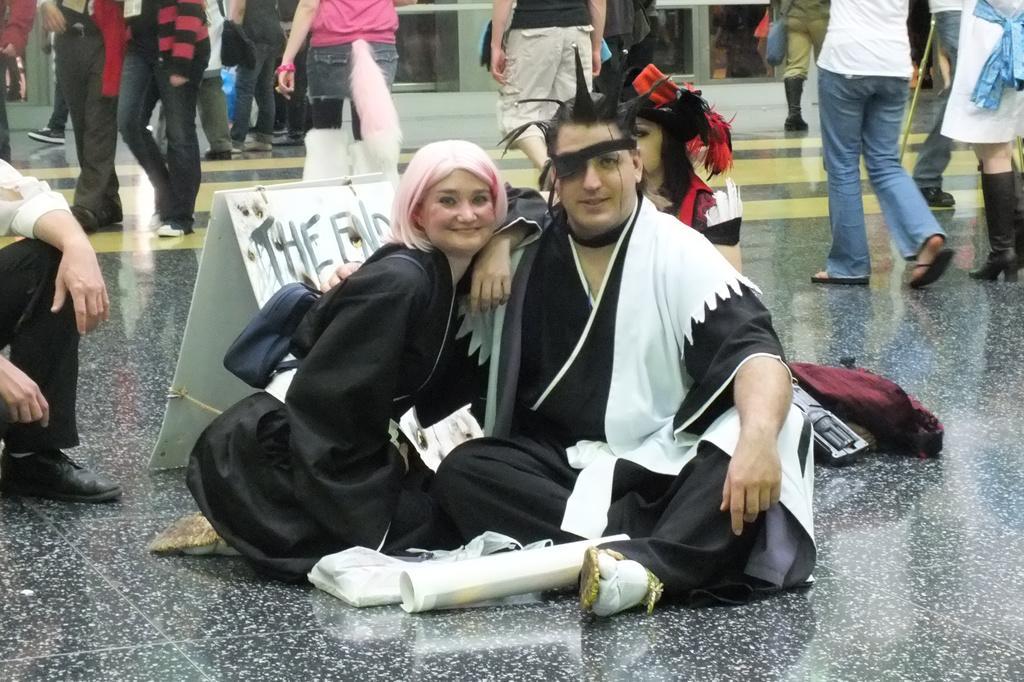Describe this image in one or two sentences. In the image there are few people sitting on the floor and posing for the photo and around them there are many people walking on the floor. 